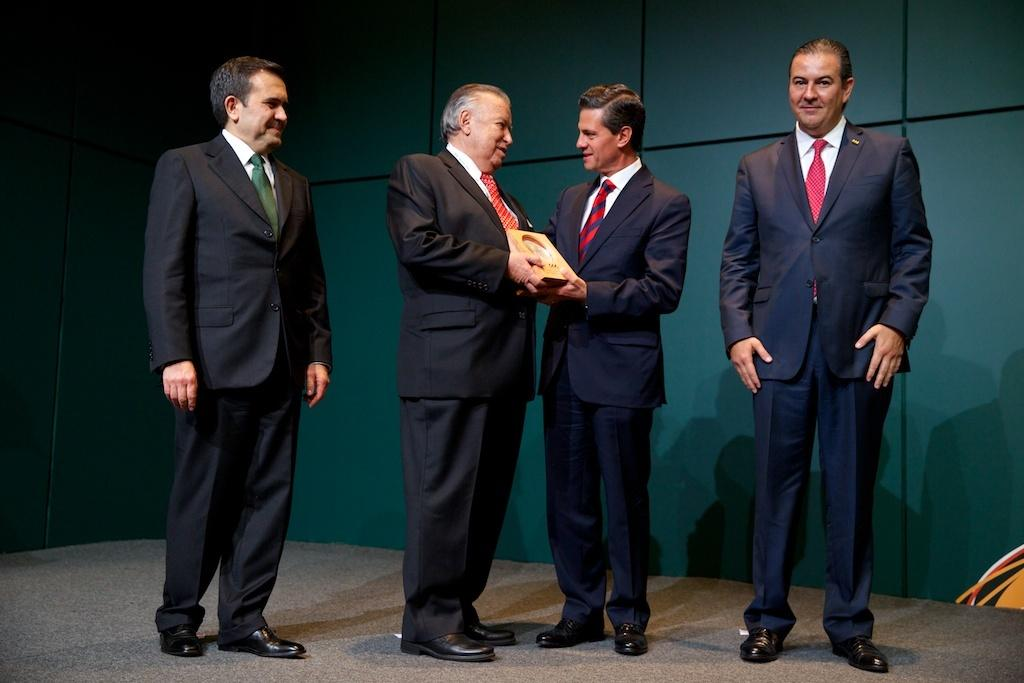How many people are in the image? There are four persons in the image. What are the persons wearing? The persons are wearing suits. What expression do the persons have? The persons are smiling. Where are the persons located in the image? The persons are standing on a stage. What are two of the persons holding? Two of the persons are holding an object. What color is the wall in the background? There is a green color wall in the background. What type of pancake is being served on the lake in the image? There is no pancake or lake present in the image. What belief system do the persons in the image follow? The image does not provide any information about the belief system of the persons. 